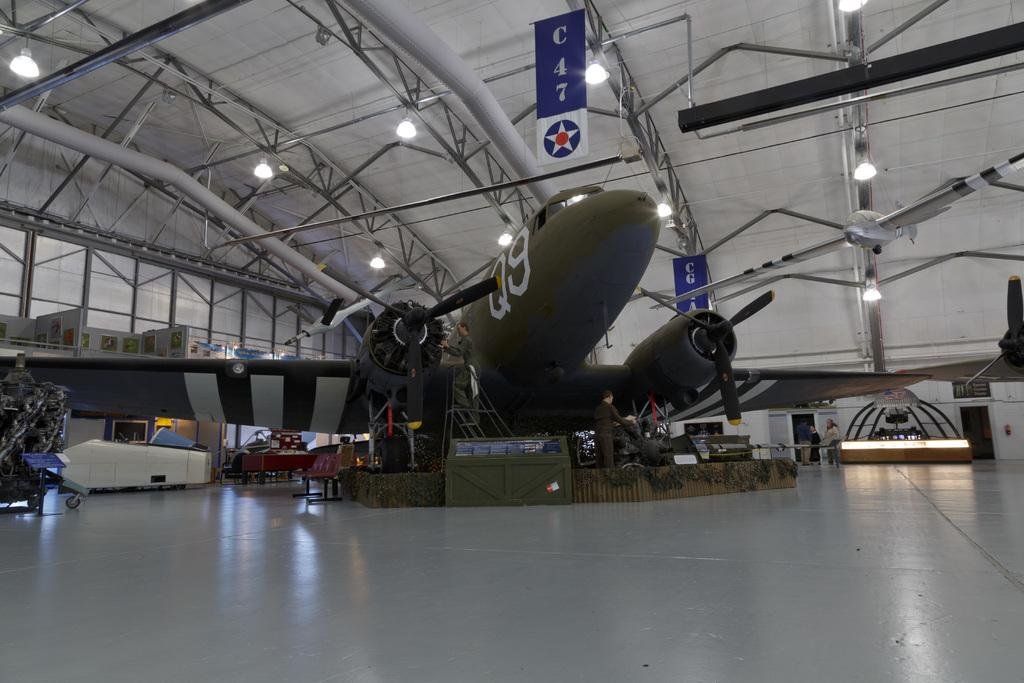Provide a one-sentence caption for the provided image. Airplane hangar that is displaying a Q9 military collection. 